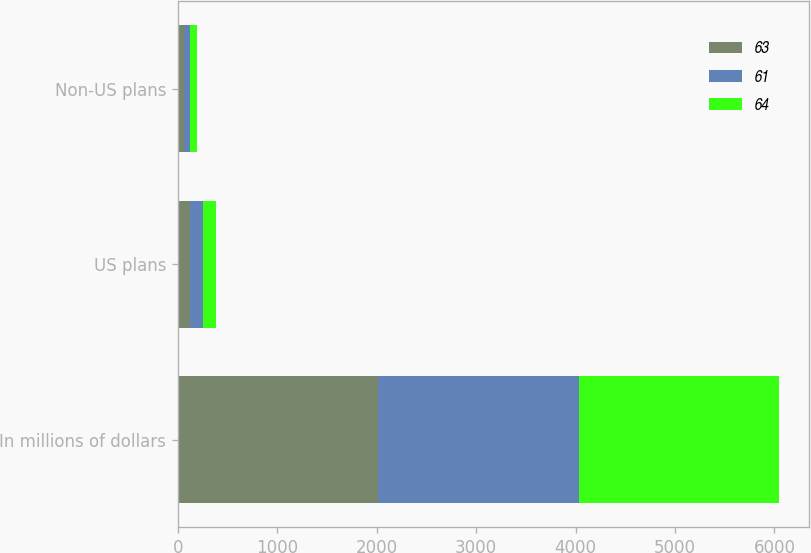<chart> <loc_0><loc_0><loc_500><loc_500><stacked_bar_chart><ecel><fcel>In millions of dollars<fcel>US plans<fcel>Non-US plans<nl><fcel>63<fcel>2017<fcel>127<fcel>64<nl><fcel>61<fcel>2016<fcel>127<fcel>61<nl><fcel>64<fcel>2015<fcel>128<fcel>63<nl></chart> 